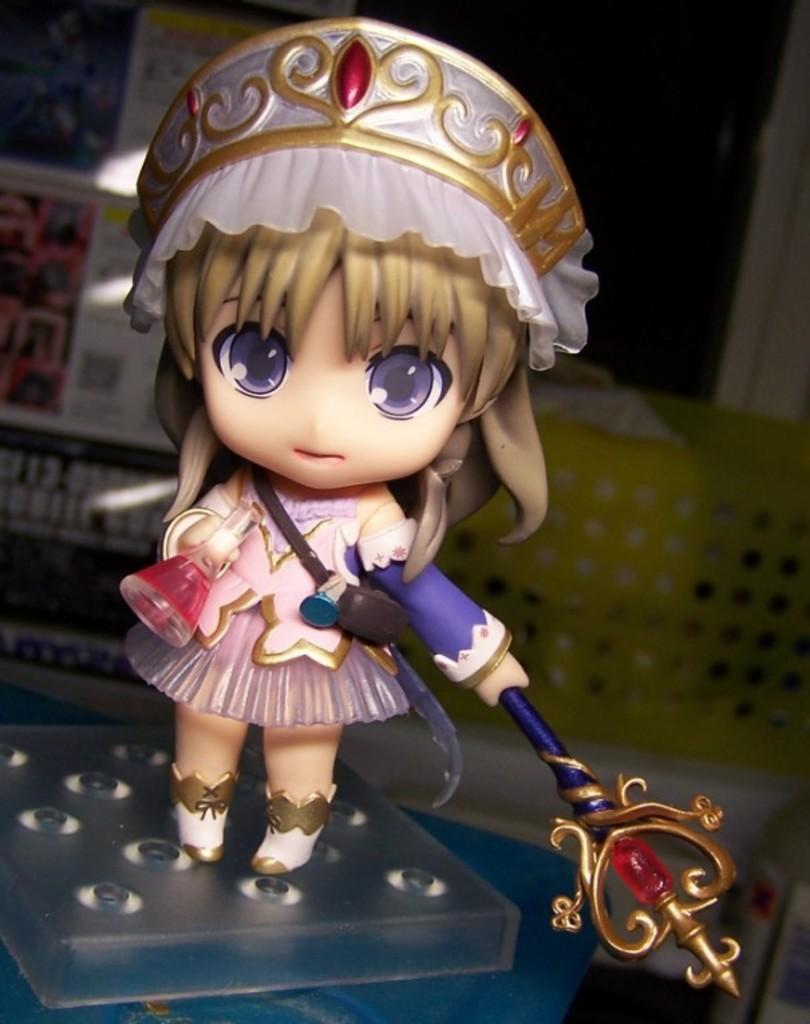Describe this image in one or two sentences. In this image I can see barbie is dressed with a pink color frock. On the head I can see a crown. In the hands I can see a bottle and another object. In the background there are some boxes. 